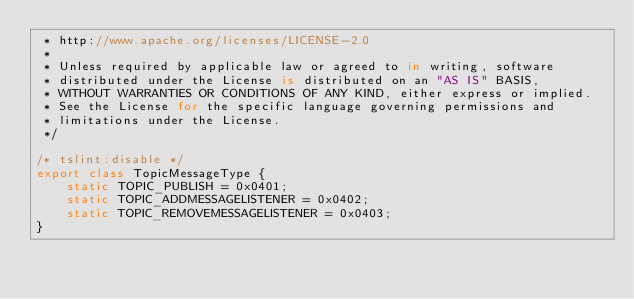Convert code to text. <code><loc_0><loc_0><loc_500><loc_500><_TypeScript_> * http://www.apache.org/licenses/LICENSE-2.0
 *
 * Unless required by applicable law or agreed to in writing, software
 * distributed under the License is distributed on an "AS IS" BASIS,
 * WITHOUT WARRANTIES OR CONDITIONS OF ANY KIND, either express or implied.
 * See the License for the specific language governing permissions and
 * limitations under the License.
 */

/* tslint:disable */
export class TopicMessageType {
    static TOPIC_PUBLISH = 0x0401;
    static TOPIC_ADDMESSAGELISTENER = 0x0402;
    static TOPIC_REMOVEMESSAGELISTENER = 0x0403;
}
</code> 